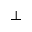Convert formula to latex. <formula><loc_0><loc_0><loc_500><loc_500>\bot</formula> 